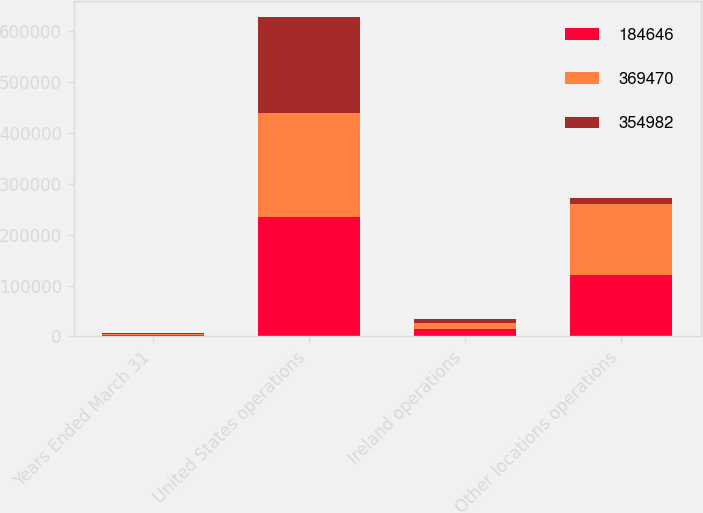<chart> <loc_0><loc_0><loc_500><loc_500><stacked_bar_chart><ecel><fcel>Years Ended March 31<fcel>United States operations<fcel>Ireland operations<fcel>Other locations operations<nl><fcel>184646<fcel>2019<fcel>235405<fcel>13693<fcel>120372<nl><fcel>369470<fcel>2018<fcel>203872<fcel>11837<fcel>139273<nl><fcel>354982<fcel>2017<fcel>189429<fcel>8597<fcel>13380<nl></chart> 